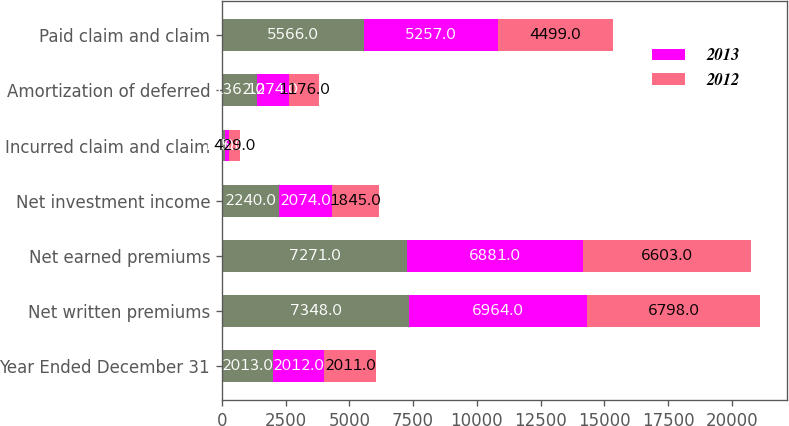<chart> <loc_0><loc_0><loc_500><loc_500><stacked_bar_chart><ecel><fcel>Year Ended December 31<fcel>Net written premiums<fcel>Net earned premiums<fcel>Net investment income<fcel>Incurred claim and claim<fcel>Amortization of deferred<fcel>Paid claim and claim<nl><fcel>nan<fcel>2013<fcel>7348<fcel>7271<fcel>2240<fcel>115<fcel>1362<fcel>5566<nl><fcel>2013<fcel>2012<fcel>6964<fcel>6881<fcel>2074<fcel>180<fcel>1274<fcel>5257<nl><fcel>2012<fcel>2011<fcel>6798<fcel>6603<fcel>1845<fcel>429<fcel>1176<fcel>4499<nl></chart> 